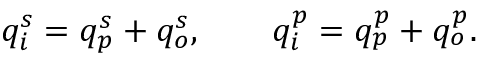Convert formula to latex. <formula><loc_0><loc_0><loc_500><loc_500>q _ { i } ^ { s } = q _ { p } ^ { s } + q _ { o } ^ { s } , \quad q _ { i } ^ { p } = q _ { p } ^ { p } + q _ { o } ^ { p } .</formula> 